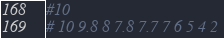<code> <loc_0><loc_0><loc_500><loc_500><_Python_>#10
# 10 9.8 8 7.8 7.7 7 6 5 4 2 </code> 